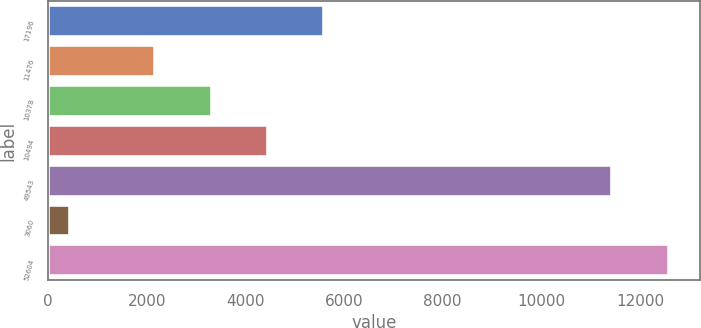Convert chart. <chart><loc_0><loc_0><loc_500><loc_500><bar_chart><fcel>17196<fcel>11476<fcel>10378<fcel>10494<fcel>49543<fcel>3060<fcel>52604<nl><fcel>5601.09<fcel>2170.5<fcel>3314.03<fcel>4457.56<fcel>11435.3<fcel>449<fcel>12578.8<nl></chart> 